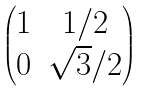<formula> <loc_0><loc_0><loc_500><loc_500>\begin{pmatrix} 1 & 1 / 2 \\ 0 & \sqrt { 3 } / 2 \end{pmatrix}</formula> 